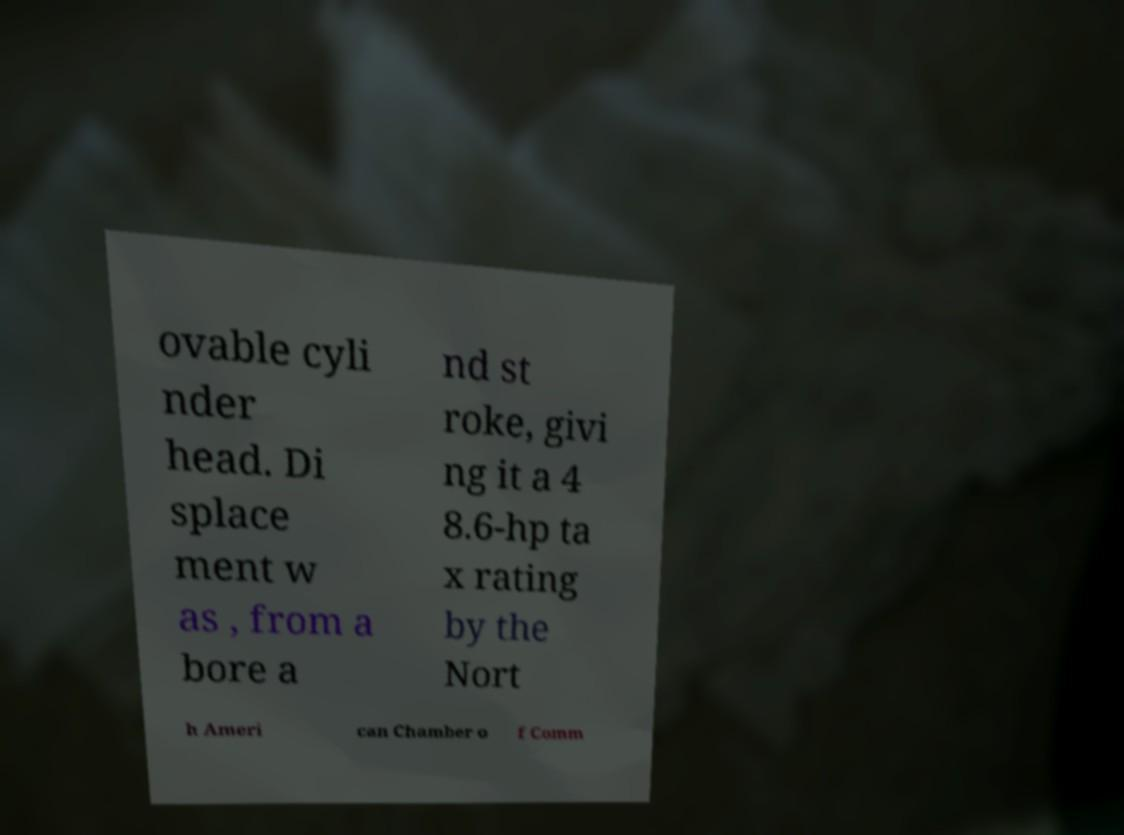Could you assist in decoding the text presented in this image and type it out clearly? ovable cyli nder head. Di splace ment w as , from a bore a nd st roke, givi ng it a 4 8.6-hp ta x rating by the Nort h Ameri can Chamber o f Comm 